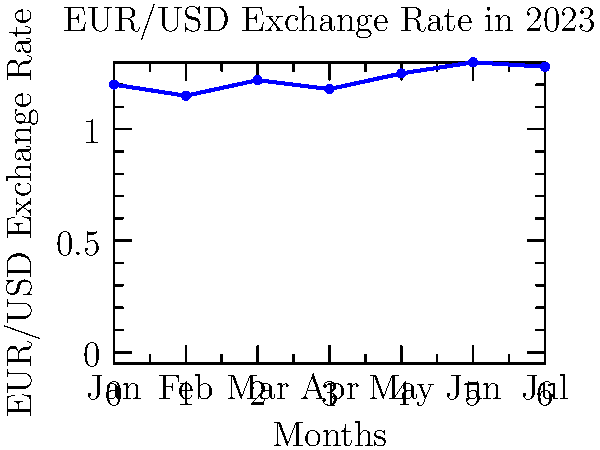As a college student dreaming of studying abroad in Europe, you're tracking the EUR/USD exchange rate. The chart shows the rate's fluctuation over the first 7 months of 2023. If you exchanged $5000 in July, how many more or fewer euros would you have received compared to if you had exchanged in February? Let's approach this step-by-step:

1. Identify the exchange rates:
   - February (Feb) rate: $1.15$ EUR/USD
   - July (Jul) rate: $1.28$ EUR/USD

2. Calculate euros received in July:
   $5000 \div 1.28 = 3906.25$ EUR

3. Calculate euros that would have been received in February:
   $5000 \div 1.15 = 4347.83$ EUR

4. Find the difference:
   $3906.25 - 4347.83 = -441.58$ EUR

The negative value indicates you would receive fewer euros in July compared to February.
Answer: 441.58 fewer euros 